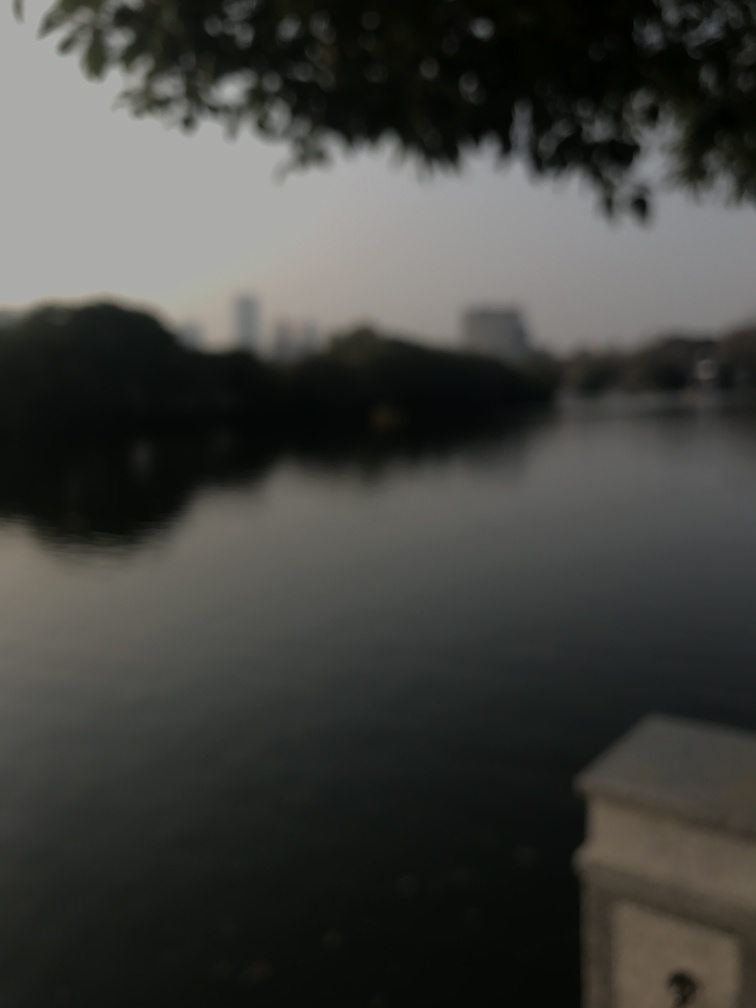Is the scene well-defined? The scene is not well-defined due to the blurriness of the image, making it difficult to ascertain specific details. The image appears to capture a body of water, possibly a lake or river, and a glimpse of foliage at the top edge suggests a natural setting. There may be structures or landscape features in the distance, but these elements are indistinct, leaving the scene's composition vague. 